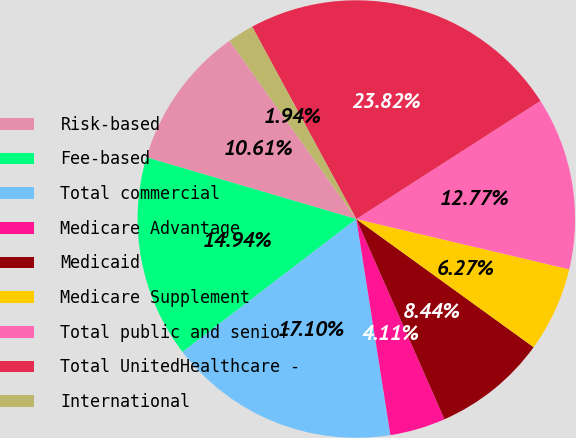Convert chart. <chart><loc_0><loc_0><loc_500><loc_500><pie_chart><fcel>Risk-based<fcel>Fee-based<fcel>Total commercial<fcel>Medicare Advantage<fcel>Medicaid<fcel>Medicare Supplement<fcel>Total public and senior<fcel>Total UnitedHealthcare -<fcel>International<nl><fcel>10.61%<fcel>14.94%<fcel>17.1%<fcel>4.11%<fcel>8.44%<fcel>6.27%<fcel>12.77%<fcel>23.82%<fcel>1.94%<nl></chart> 